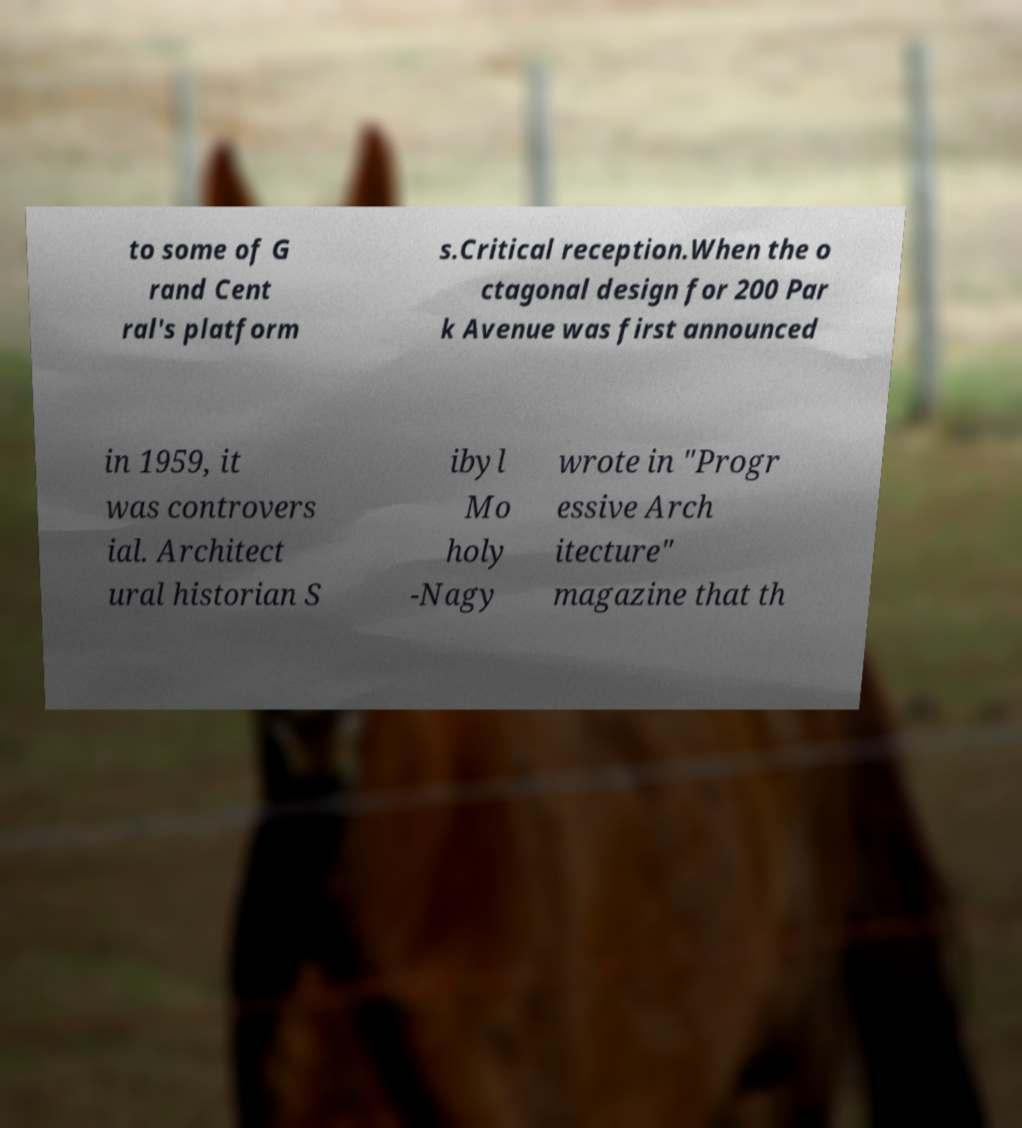Could you assist in decoding the text presented in this image and type it out clearly? to some of G rand Cent ral's platform s.Critical reception.When the o ctagonal design for 200 Par k Avenue was first announced in 1959, it was controvers ial. Architect ural historian S ibyl Mo holy -Nagy wrote in "Progr essive Arch itecture" magazine that th 